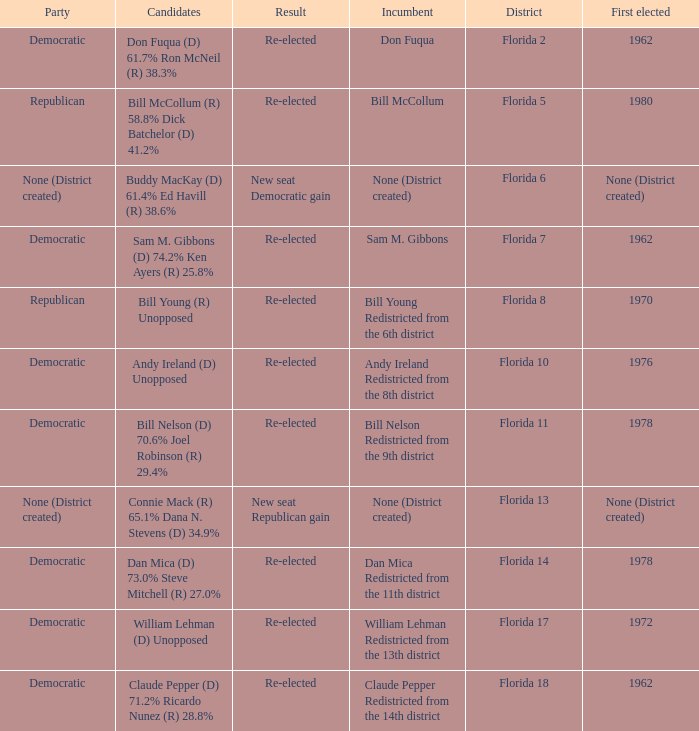What's the first elected with district being florida 7 1962.0. I'm looking to parse the entire table for insights. Could you assist me with that? {'header': ['Party', 'Candidates', 'Result', 'Incumbent', 'District', 'First elected'], 'rows': [['Democratic', 'Don Fuqua (D) 61.7% Ron McNeil (R) 38.3%', 'Re-elected', 'Don Fuqua', 'Florida 2', '1962'], ['Republican', 'Bill McCollum (R) 58.8% Dick Batchelor (D) 41.2%', 'Re-elected', 'Bill McCollum', 'Florida 5', '1980'], ['None (District created)', 'Buddy MacKay (D) 61.4% Ed Havill (R) 38.6%', 'New seat Democratic gain', 'None (District created)', 'Florida 6', 'None (District created)'], ['Democratic', 'Sam M. Gibbons (D) 74.2% Ken Ayers (R) 25.8%', 'Re-elected', 'Sam M. Gibbons', 'Florida 7', '1962'], ['Republican', 'Bill Young (R) Unopposed', 'Re-elected', 'Bill Young Redistricted from the 6th district', 'Florida 8', '1970'], ['Democratic', 'Andy Ireland (D) Unopposed', 'Re-elected', 'Andy Ireland Redistricted from the 8th district', 'Florida 10', '1976'], ['Democratic', 'Bill Nelson (D) 70.6% Joel Robinson (R) 29.4%', 'Re-elected', 'Bill Nelson Redistricted from the 9th district', 'Florida 11', '1978'], ['None (District created)', 'Connie Mack (R) 65.1% Dana N. Stevens (D) 34.9%', 'New seat Republican gain', 'None (District created)', 'Florida 13', 'None (District created)'], ['Democratic', 'Dan Mica (D) 73.0% Steve Mitchell (R) 27.0%', 'Re-elected', 'Dan Mica Redistricted from the 11th district', 'Florida 14', '1978'], ['Democratic', 'William Lehman (D) Unopposed', 'Re-elected', 'William Lehman Redistricted from the 13th district', 'Florida 17', '1972'], ['Democratic', 'Claude Pepper (D) 71.2% Ricardo Nunez (R) 28.8%', 'Re-elected', 'Claude Pepper Redistricted from the 14th district', 'Florida 18', '1962']]} 